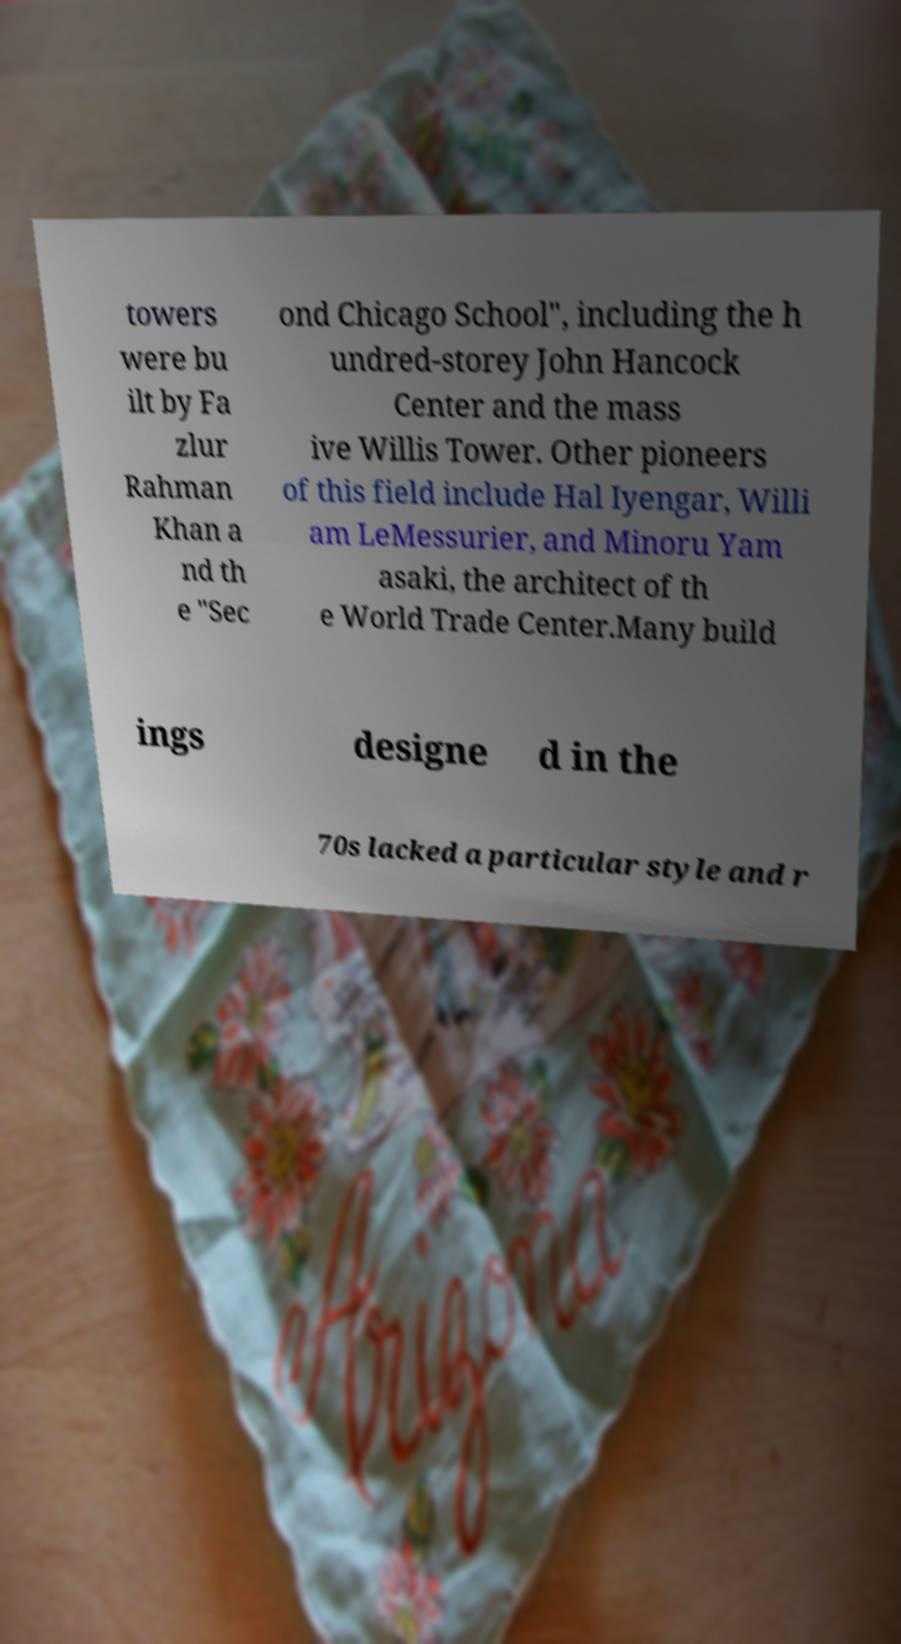Could you extract and type out the text from this image? towers were bu ilt by Fa zlur Rahman Khan a nd th e "Sec ond Chicago School", including the h undred-storey John Hancock Center and the mass ive Willis Tower. Other pioneers of this field include Hal Iyengar, Willi am LeMessurier, and Minoru Yam asaki, the architect of th e World Trade Center.Many build ings designe d in the 70s lacked a particular style and r 